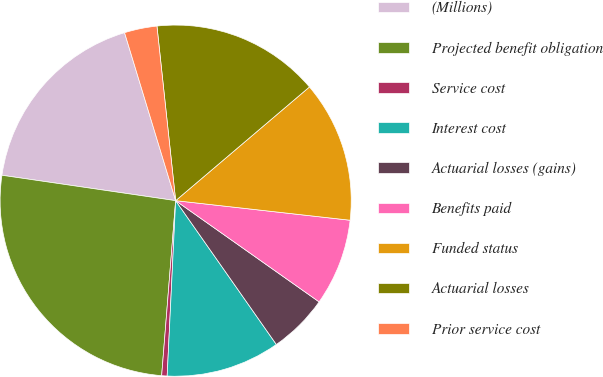Convert chart to OTSL. <chart><loc_0><loc_0><loc_500><loc_500><pie_chart><fcel>(Millions)<fcel>Projected benefit obligation<fcel>Service cost<fcel>Interest cost<fcel>Actuarial losses (gains)<fcel>Benefits paid<fcel>Funded status<fcel>Actuarial losses<fcel>Prior service cost<nl><fcel>17.99%<fcel>26.04%<fcel>0.5%<fcel>10.49%<fcel>5.5%<fcel>8.0%<fcel>12.99%<fcel>15.49%<fcel>3.0%<nl></chart> 